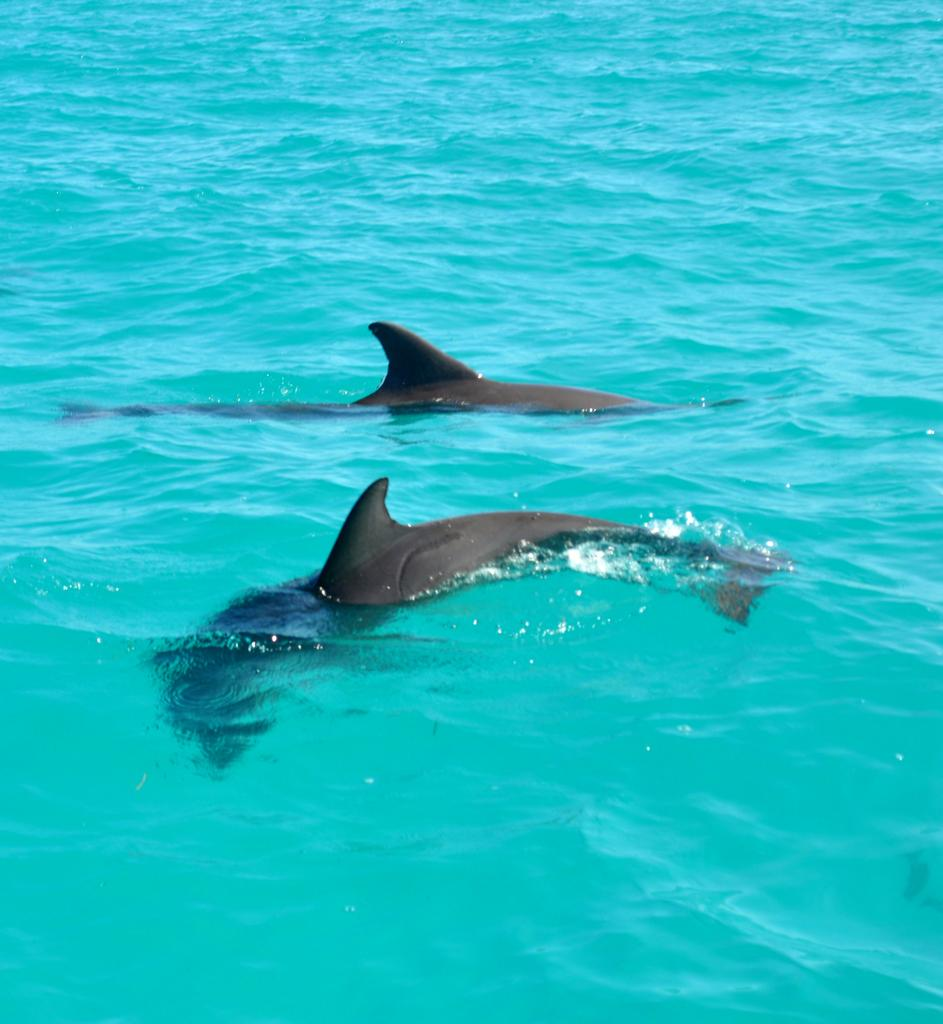How many dolphins are present in the image? There are 2 dolphins in the image. Where are the dolphins located? The dolphins are in a pool of water. What is the price of the door in the image? There is no door present in the image, as it features dolphins in a pool of water. 